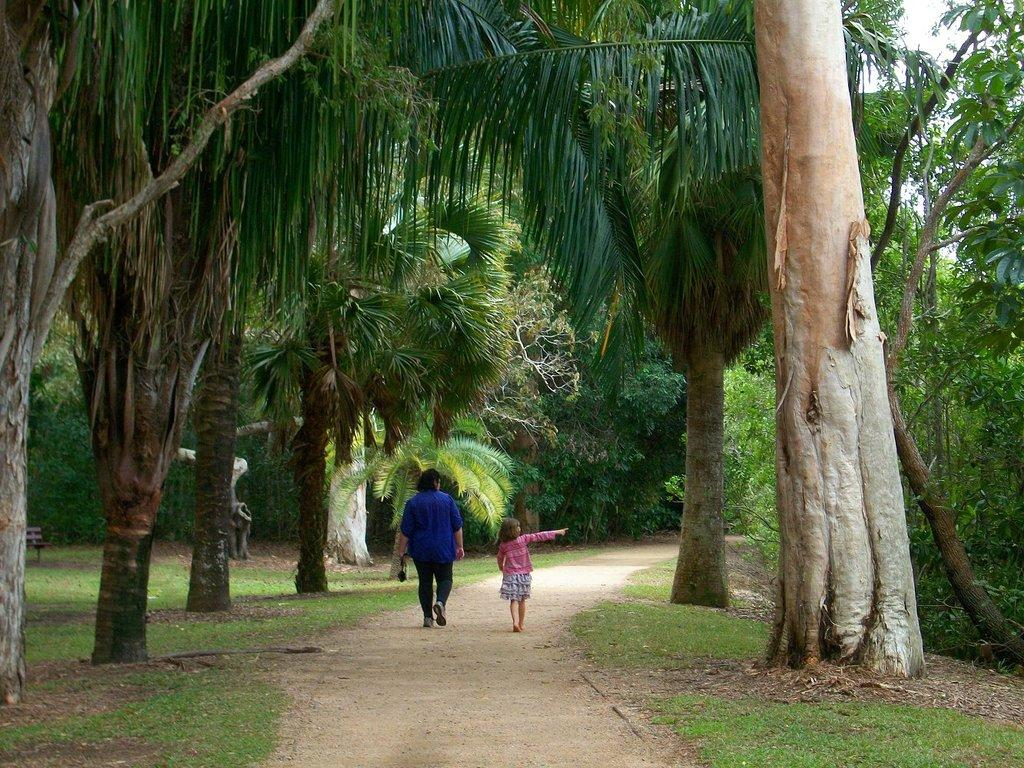What are the people in the image doing? There are persons walking in the center of the image. What type of ground can be seen in the front of the image? There is grass on the ground in the front of the image. What can be seen in the background of the image? There are trees in the background of the image. What type of badge is being worn by the trees in the background? There are no badges present in the image, and the trees do not wear badges. How does the quartz affect the wind in the image? There is no quartz present in the image, and therefore no effect on the wind can be observed. 